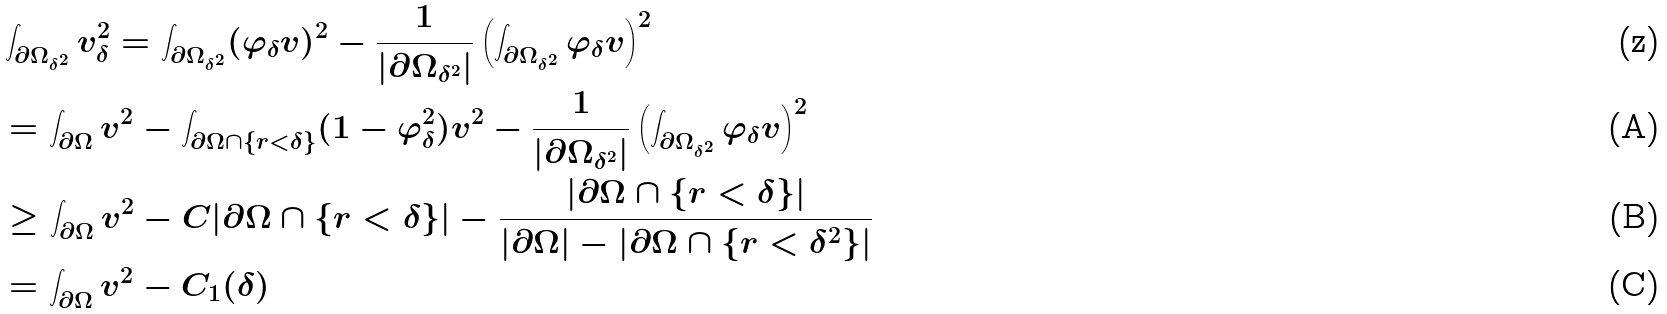Convert formula to latex. <formula><loc_0><loc_0><loc_500><loc_500>& \int _ { \partial \Omega _ { \delta ^ { 2 } } } v _ { \delta } ^ { 2 } = \int _ { \partial \Omega _ { \delta ^ { 2 } } } ( \varphi _ { \delta } v ) ^ { 2 } - \frac { 1 } { | \partial \Omega _ { \delta ^ { 2 } } | } \left ( \int _ { \partial \Omega _ { \delta ^ { 2 } } } \varphi _ { \delta } v \right ) ^ { 2 } \\ & = \int _ { \partial \Omega } v ^ { 2 } - \int _ { \partial \Omega \cap \{ r < \delta \} } ( 1 - \varphi _ { \delta } ^ { 2 } ) v ^ { 2 } - \frac { 1 } { | \partial \Omega _ { \delta ^ { 2 } } | } \left ( \int _ { \partial \Omega _ { \delta ^ { 2 } } } \varphi _ { \delta } v \right ) ^ { 2 } \\ & \geq \int _ { \partial \Omega } v ^ { 2 } - C | \partial \Omega \cap \{ r < \delta \} | - \frac { | \partial \Omega \cap \{ r < \delta \} | } { | \partial \Omega | - | \partial \Omega \cap \{ r < \delta ^ { 2 } \} | } \\ & = \int _ { \partial \Omega } v ^ { 2 } - C _ { 1 } ( \delta )</formula> 